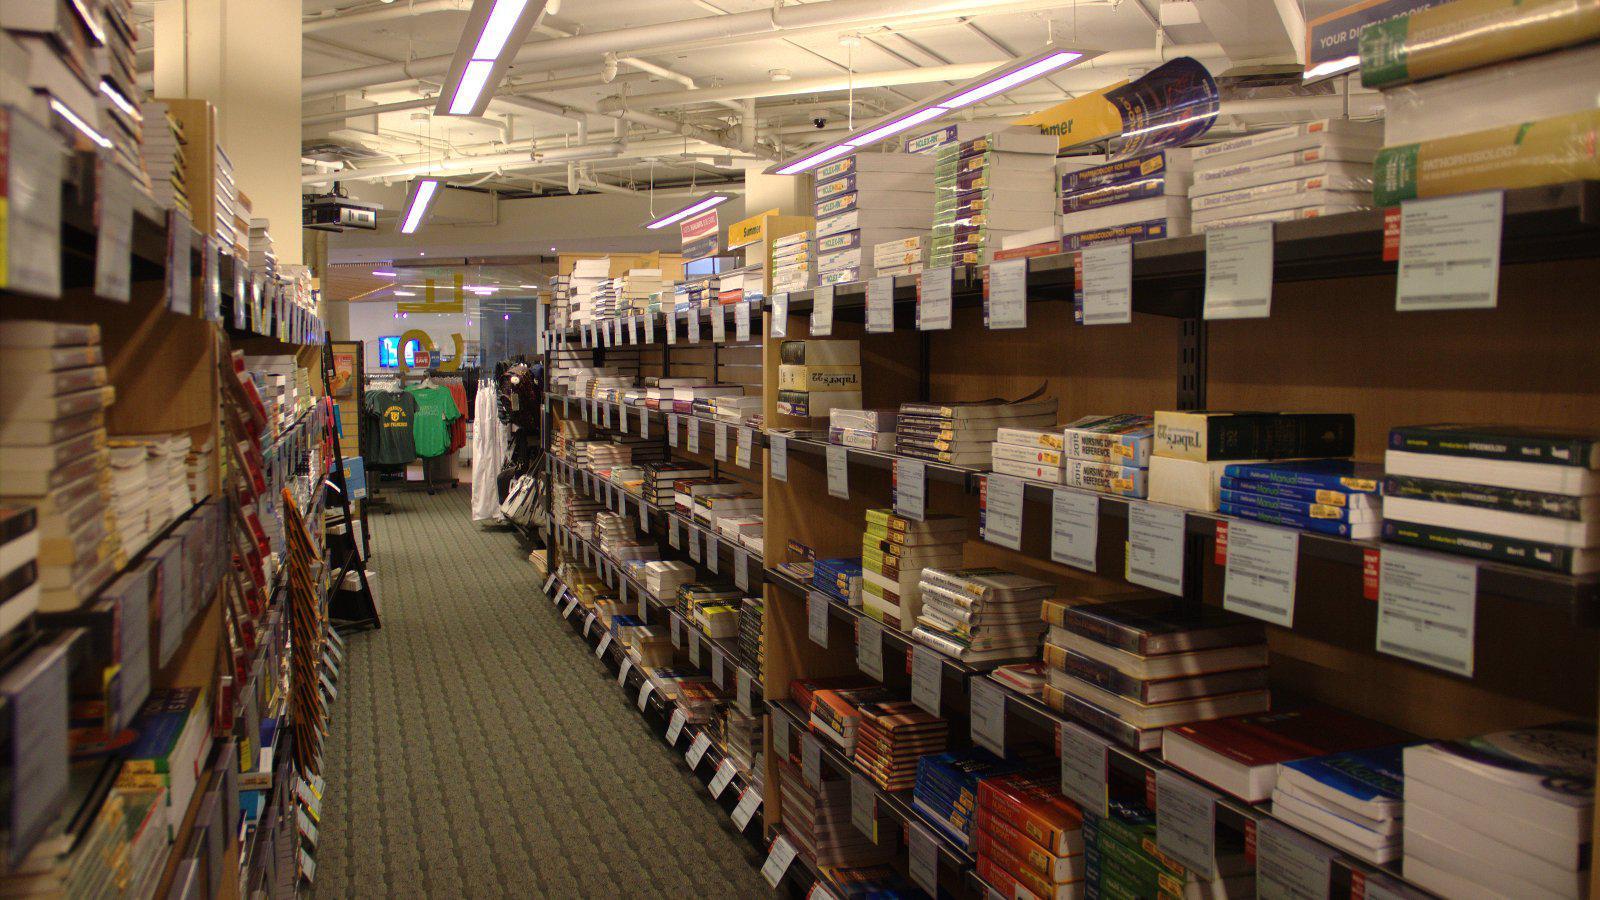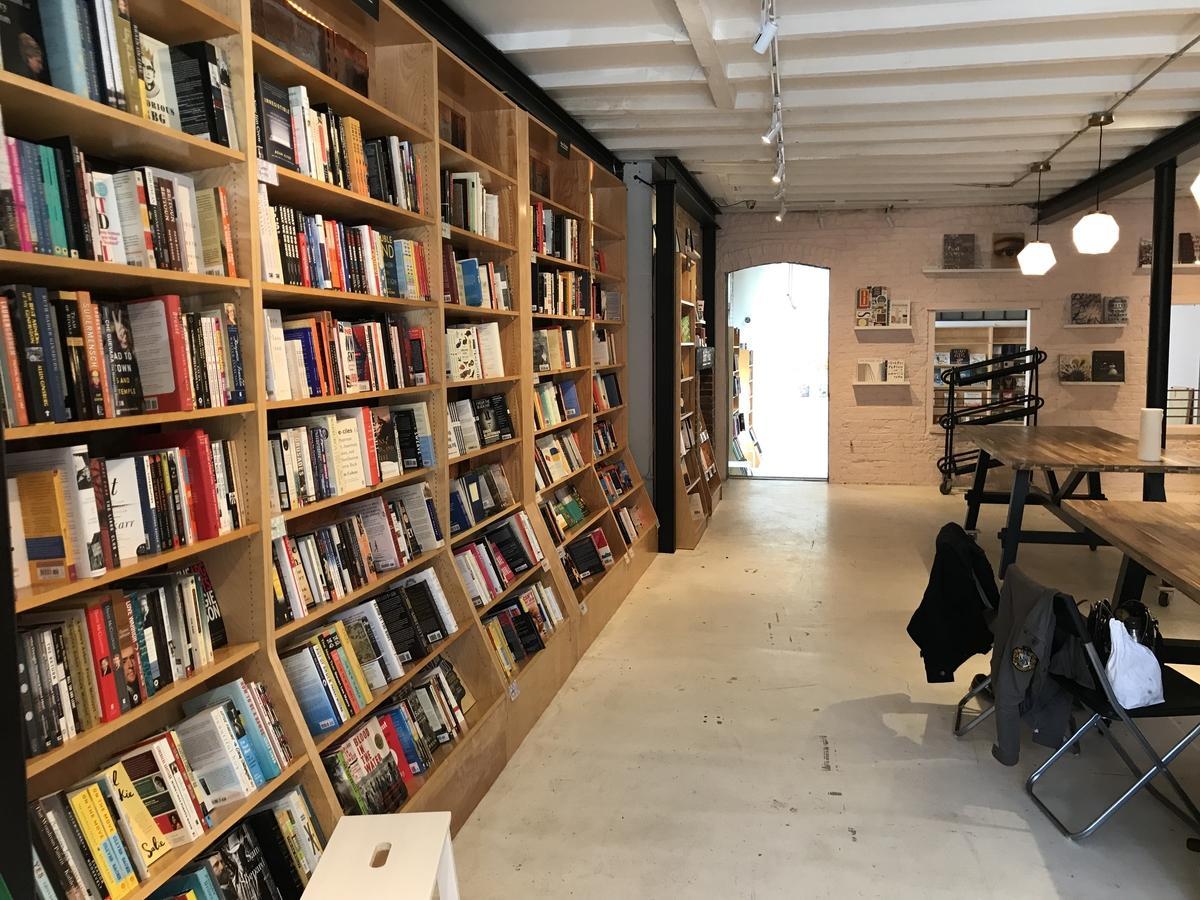The first image is the image on the left, the second image is the image on the right. Assess this claim about the two images: "People are walking through the aisles of books in each of the images.". Correct or not? Answer yes or no. No. The first image is the image on the left, the second image is the image on the right. Assess this claim about the two images: "The left and right images show someone standing at the end of an aisle of books, but not in front of a table display.". Correct or not? Answer yes or no. No. 